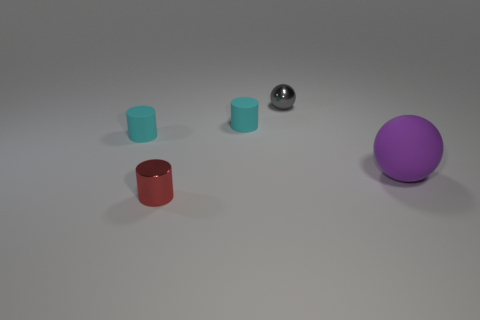Subtract all small red cylinders. How many cylinders are left? 2 Add 2 gray things. How many objects exist? 7 Subtract all red cylinders. How many cylinders are left? 2 Subtract all red balls. How many cyan cylinders are left? 2 Subtract 2 balls. How many balls are left? 0 Add 4 cyan rubber cylinders. How many cyan rubber cylinders exist? 6 Subtract 0 red spheres. How many objects are left? 5 Subtract all balls. How many objects are left? 3 Subtract all blue spheres. Subtract all purple cylinders. How many spheres are left? 2 Subtract all tiny blue blocks. Subtract all gray metal balls. How many objects are left? 4 